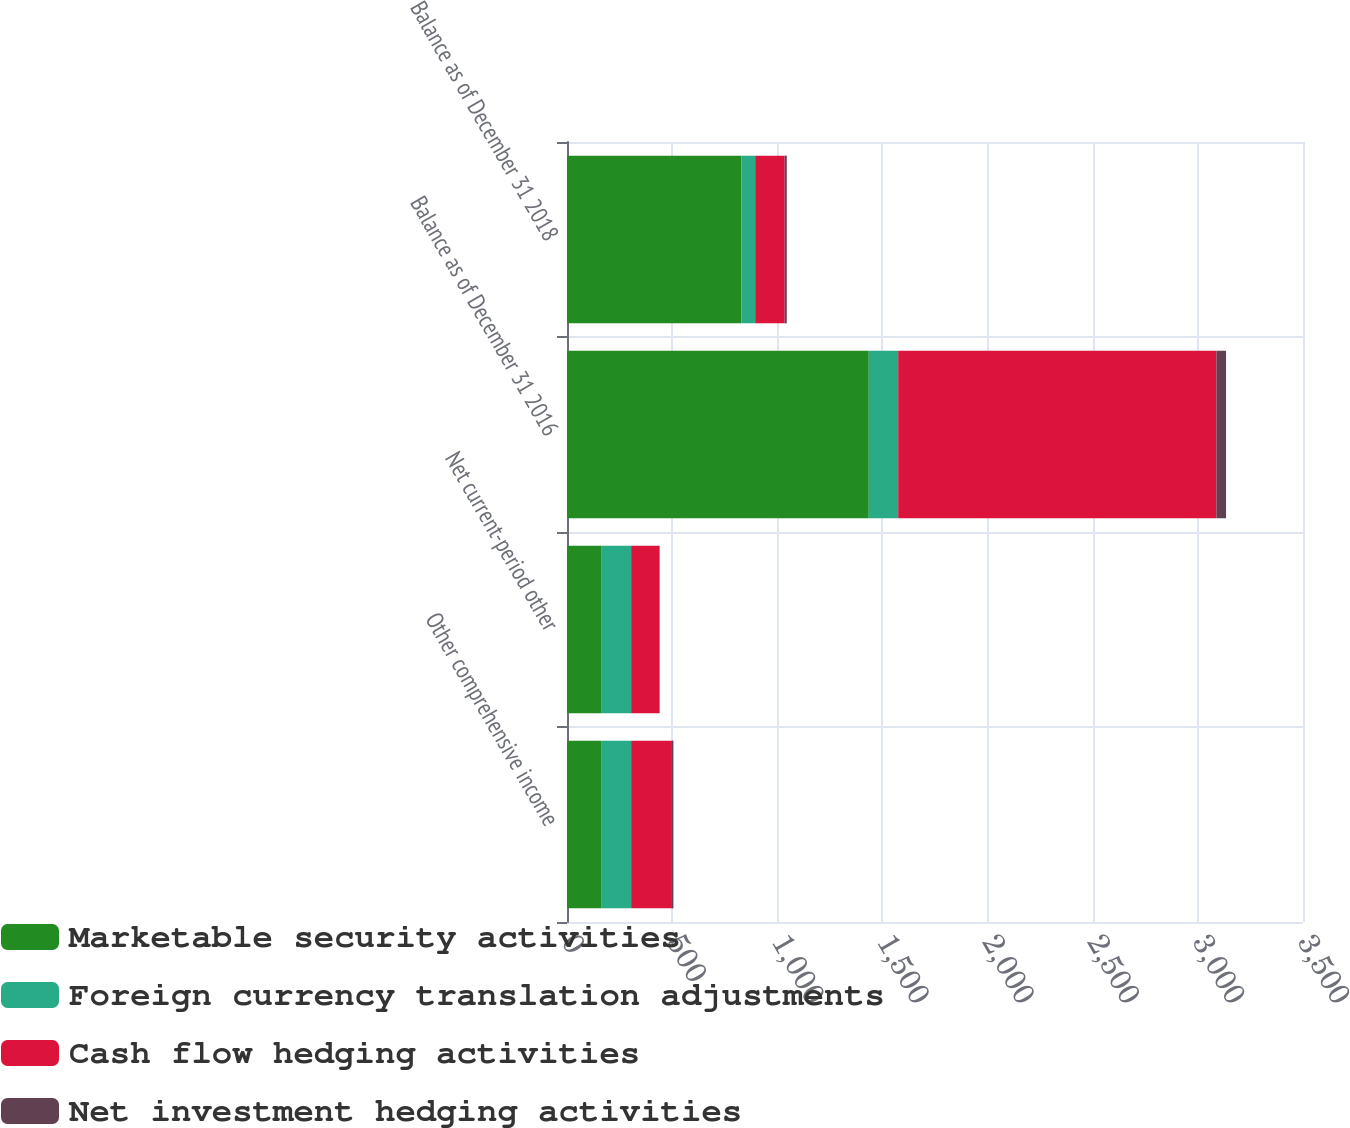<chart> <loc_0><loc_0><loc_500><loc_500><stacked_bar_chart><ecel><fcel>Other comprehensive income<fcel>Net current-period other<fcel>Balance as of December 31 2016<fcel>Balance as of December 31 2018<nl><fcel>Marketable security activities<fcel>165<fcel>165<fcel>1435<fcel>830<nl><fcel>Foreign currency translation adjustments<fcel>140<fcel>140<fcel>140<fcel>65<nl><fcel>Cash flow hedging activities<fcel>194<fcel>135<fcel>1513<fcel>140<nl><fcel>Net investment hedging activities<fcel>7<fcel>1<fcel>46<fcel>10<nl></chart> 